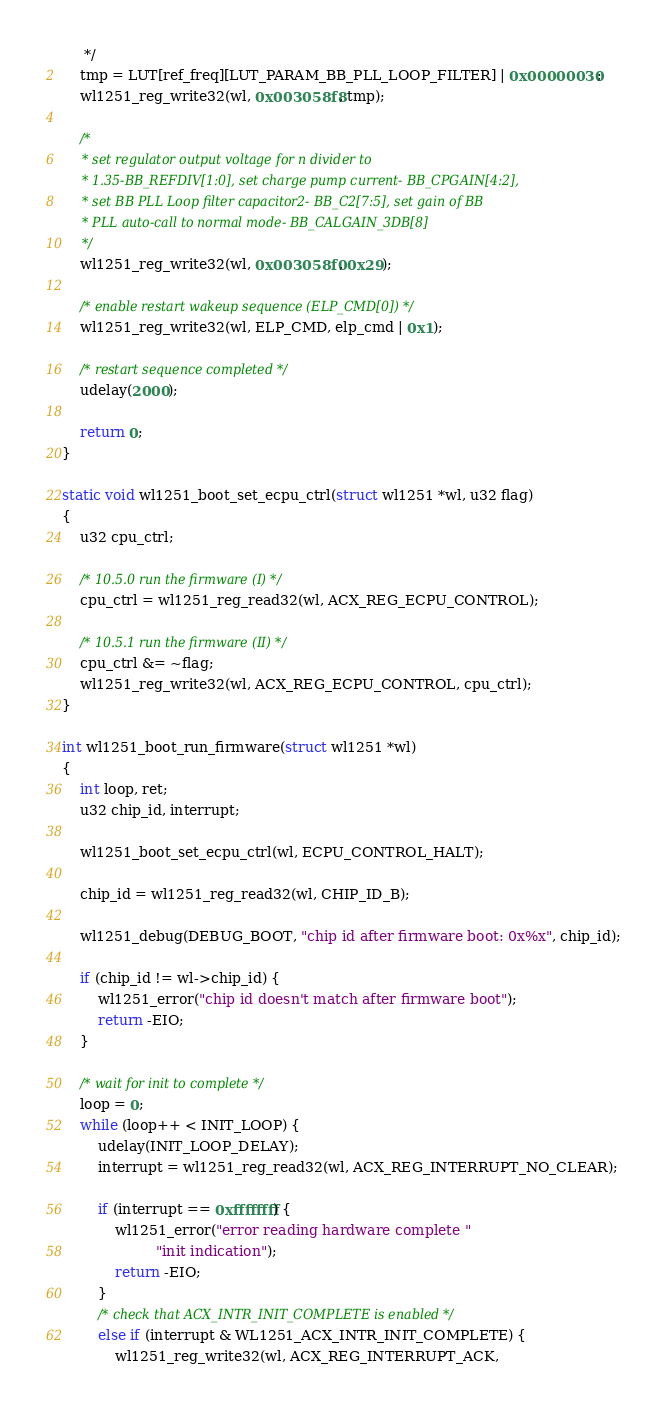<code> <loc_0><loc_0><loc_500><loc_500><_C_>	 */
	tmp = LUT[ref_freq][LUT_PARAM_BB_PLL_LOOP_FILTER] | 0x00000030;
	wl1251_reg_write32(wl, 0x003058f8, tmp);

	/*
	 * set regulator output voltage for n divider to
	 * 1.35-BB_REFDIV[1:0], set charge pump current- BB_CPGAIN[4:2],
	 * set BB PLL Loop filter capacitor2- BB_C2[7:5], set gain of BB
	 * PLL auto-call to normal mode- BB_CALGAIN_3DB[8]
	 */
	wl1251_reg_write32(wl, 0x003058f0, 0x29);

	/* enable restart wakeup sequence (ELP_CMD[0]) */
	wl1251_reg_write32(wl, ELP_CMD, elp_cmd | 0x1);

	/* restart sequence completed */
	udelay(2000);

	return 0;
}

static void wl1251_boot_set_ecpu_ctrl(struct wl1251 *wl, u32 flag)
{
	u32 cpu_ctrl;

	/* 10.5.0 run the firmware (I) */
	cpu_ctrl = wl1251_reg_read32(wl, ACX_REG_ECPU_CONTROL);

	/* 10.5.1 run the firmware (II) */
	cpu_ctrl &= ~flag;
	wl1251_reg_write32(wl, ACX_REG_ECPU_CONTROL, cpu_ctrl);
}

int wl1251_boot_run_firmware(struct wl1251 *wl)
{
	int loop, ret;
	u32 chip_id, interrupt;

	wl1251_boot_set_ecpu_ctrl(wl, ECPU_CONTROL_HALT);

	chip_id = wl1251_reg_read32(wl, CHIP_ID_B);

	wl1251_debug(DEBUG_BOOT, "chip id after firmware boot: 0x%x", chip_id);

	if (chip_id != wl->chip_id) {
		wl1251_error("chip id doesn't match after firmware boot");
		return -EIO;
	}

	/* wait for init to complete */
	loop = 0;
	while (loop++ < INIT_LOOP) {
		udelay(INIT_LOOP_DELAY);
		interrupt = wl1251_reg_read32(wl, ACX_REG_INTERRUPT_NO_CLEAR);

		if (interrupt == 0xffffffff) {
			wl1251_error("error reading hardware complete "
				     "init indication");
			return -EIO;
		}
		/* check that ACX_INTR_INIT_COMPLETE is enabled */
		else if (interrupt & WL1251_ACX_INTR_INIT_COMPLETE) {
			wl1251_reg_write32(wl, ACX_REG_INTERRUPT_ACK,</code> 